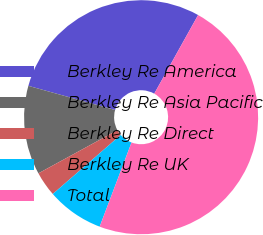<chart> <loc_0><loc_0><loc_500><loc_500><pie_chart><fcel>Berkley Re America<fcel>Berkley Re Asia Pacific<fcel>Berkley Re Direct<fcel>Berkley Re UK<fcel>Total<nl><fcel>28.78%<fcel>12.28%<fcel>3.43%<fcel>7.85%<fcel>47.66%<nl></chart> 